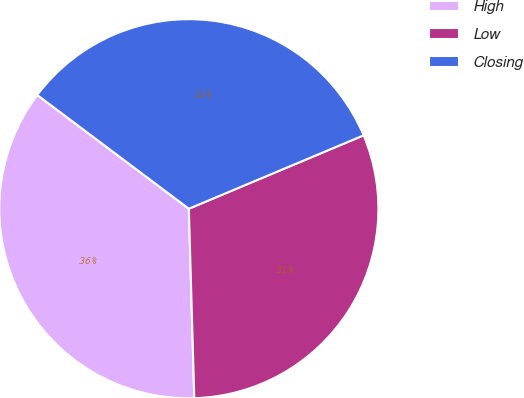Convert chart to OTSL. <chart><loc_0><loc_0><loc_500><loc_500><pie_chart><fcel>High<fcel>Low<fcel>Closing<nl><fcel>35.7%<fcel>30.87%<fcel>33.43%<nl></chart> 